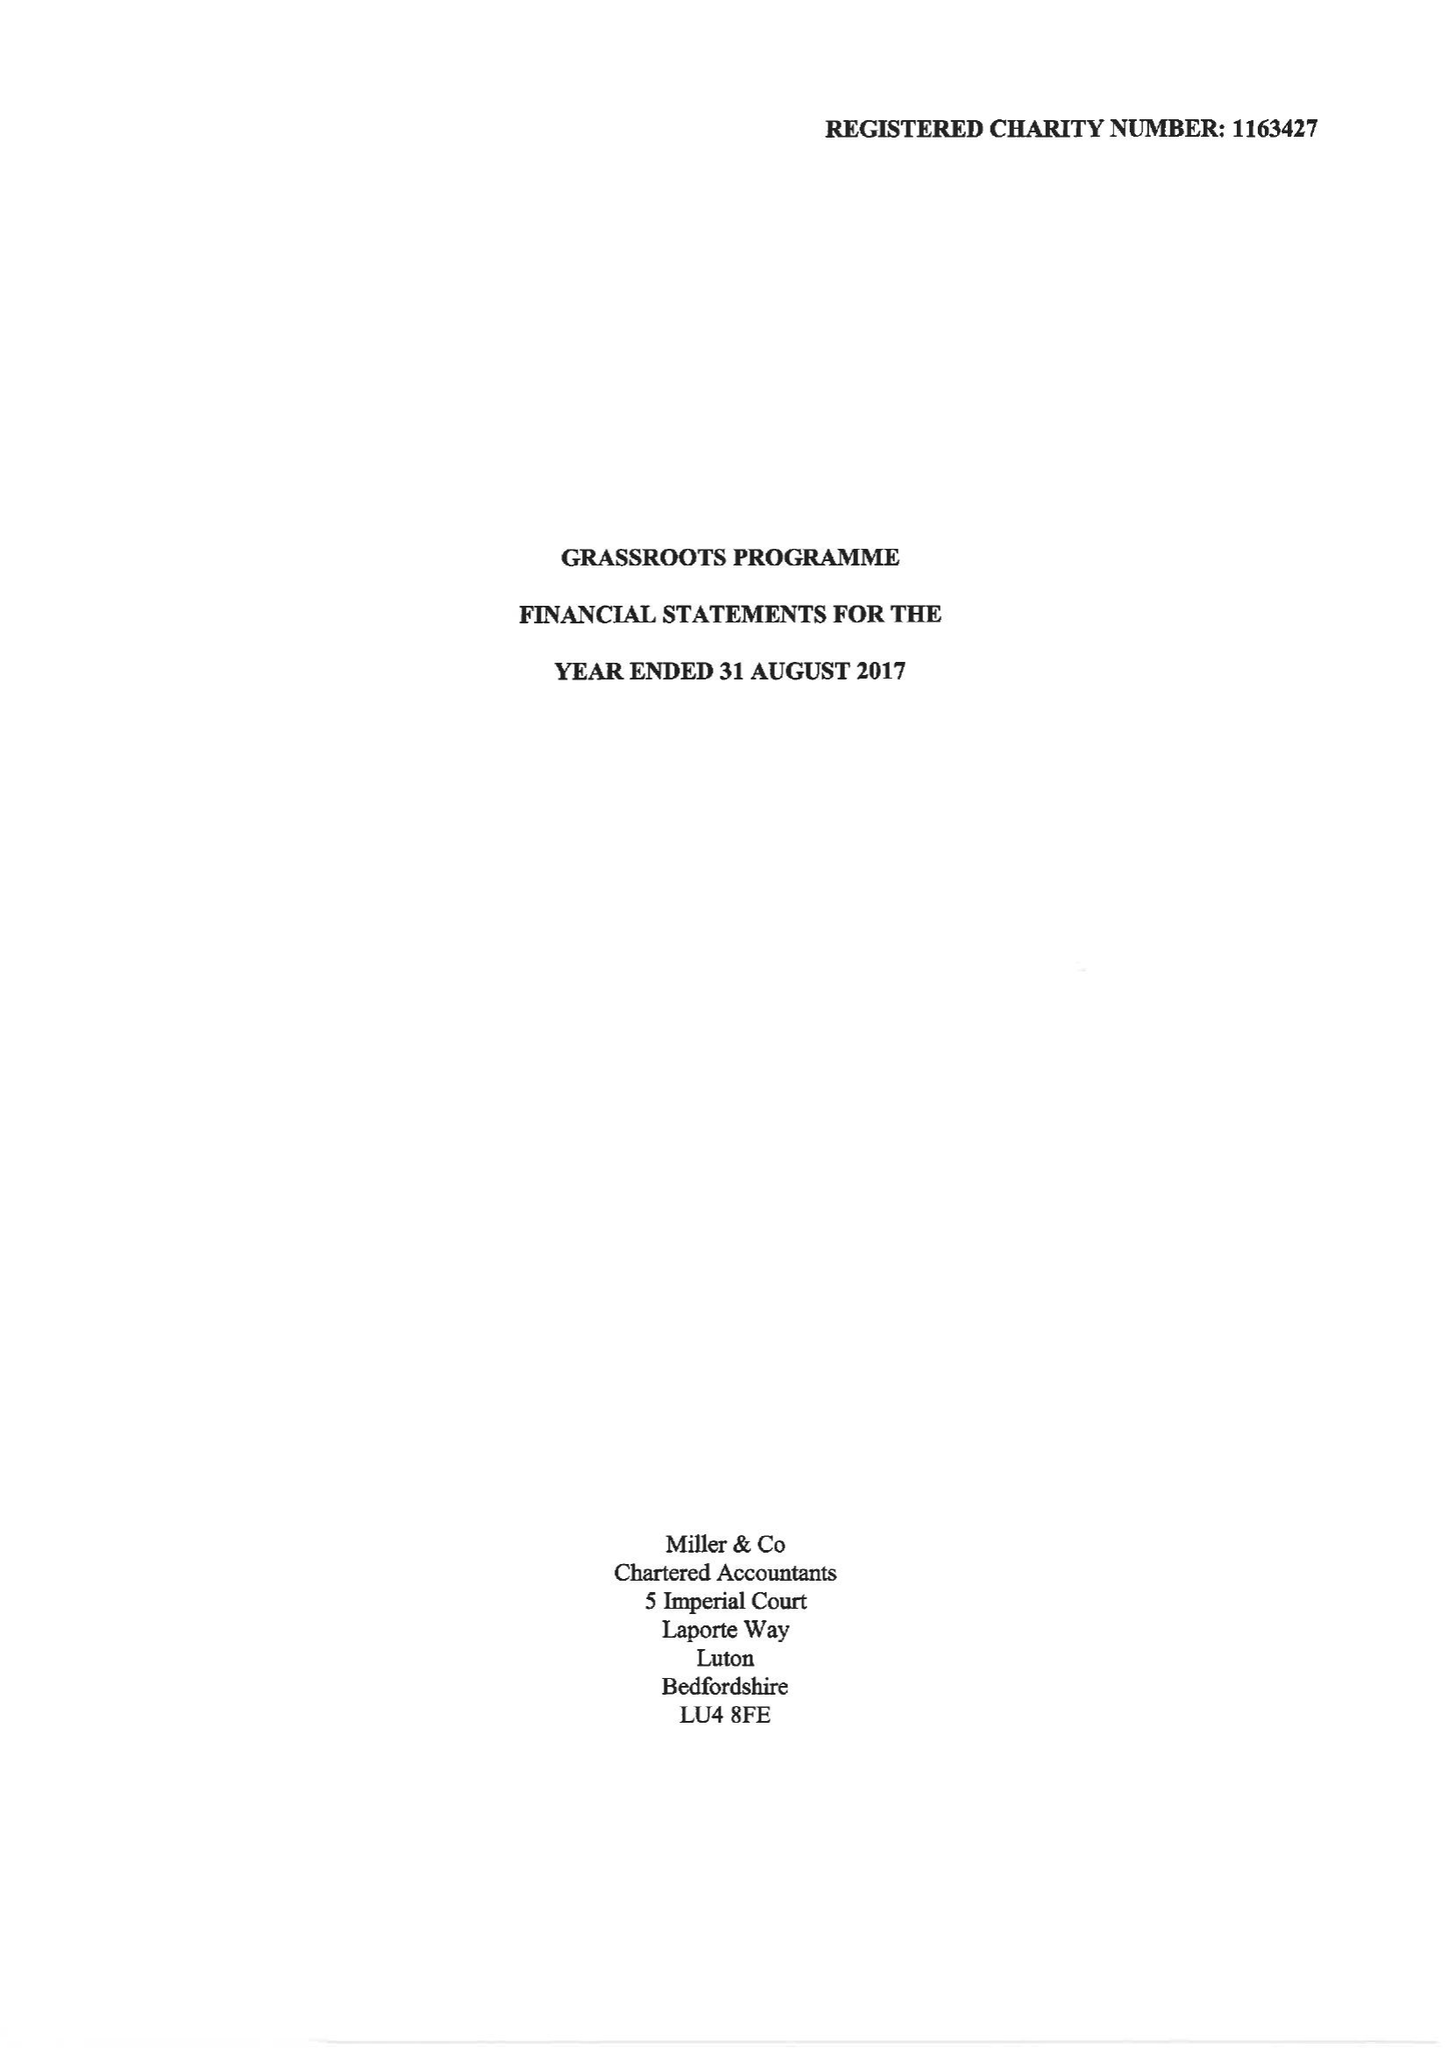What is the value for the charity_number?
Answer the question using a single word or phrase. 1163427 